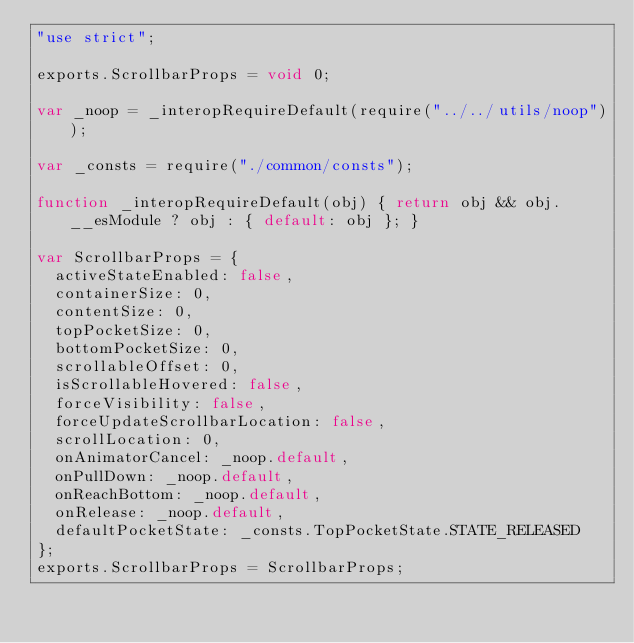Convert code to text. <code><loc_0><loc_0><loc_500><loc_500><_JavaScript_>"use strict";

exports.ScrollbarProps = void 0;

var _noop = _interopRequireDefault(require("../../utils/noop"));

var _consts = require("./common/consts");

function _interopRequireDefault(obj) { return obj && obj.__esModule ? obj : { default: obj }; }

var ScrollbarProps = {
  activeStateEnabled: false,
  containerSize: 0,
  contentSize: 0,
  topPocketSize: 0,
  bottomPocketSize: 0,
  scrollableOffset: 0,
  isScrollableHovered: false,
  forceVisibility: false,
  forceUpdateScrollbarLocation: false,
  scrollLocation: 0,
  onAnimatorCancel: _noop.default,
  onPullDown: _noop.default,
  onReachBottom: _noop.default,
  onRelease: _noop.default,
  defaultPocketState: _consts.TopPocketState.STATE_RELEASED
};
exports.ScrollbarProps = ScrollbarProps;</code> 